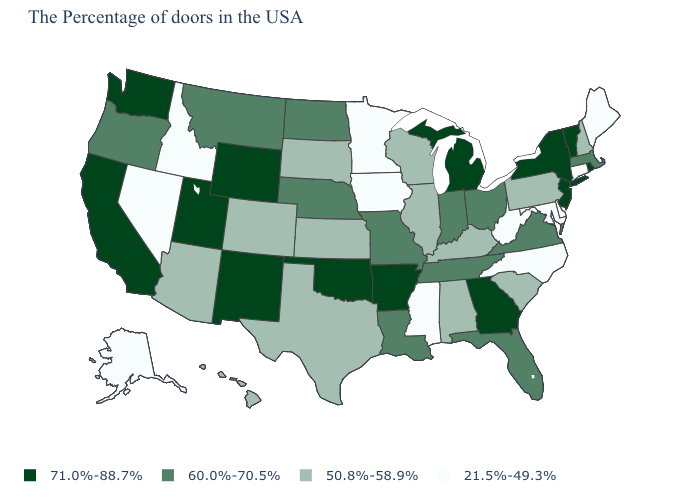Which states have the lowest value in the USA?
Give a very brief answer. Maine, Connecticut, Delaware, Maryland, North Carolina, West Virginia, Mississippi, Minnesota, Iowa, Idaho, Nevada, Alaska. Name the states that have a value in the range 50.8%-58.9%?
Keep it brief. New Hampshire, Pennsylvania, South Carolina, Kentucky, Alabama, Wisconsin, Illinois, Kansas, Texas, South Dakota, Colorado, Arizona, Hawaii. Does Alaska have the lowest value in the USA?
Concise answer only. Yes. What is the value of Oregon?
Short answer required. 60.0%-70.5%. Which states have the lowest value in the USA?
Give a very brief answer. Maine, Connecticut, Delaware, Maryland, North Carolina, West Virginia, Mississippi, Minnesota, Iowa, Idaho, Nevada, Alaska. What is the value of Kentucky?
Keep it brief. 50.8%-58.9%. Does New Hampshire have the highest value in the Northeast?
Be succinct. No. What is the value of Pennsylvania?
Give a very brief answer. 50.8%-58.9%. What is the value of Delaware?
Give a very brief answer. 21.5%-49.3%. Name the states that have a value in the range 21.5%-49.3%?
Keep it brief. Maine, Connecticut, Delaware, Maryland, North Carolina, West Virginia, Mississippi, Minnesota, Iowa, Idaho, Nevada, Alaska. Which states have the lowest value in the USA?
Give a very brief answer. Maine, Connecticut, Delaware, Maryland, North Carolina, West Virginia, Mississippi, Minnesota, Iowa, Idaho, Nevada, Alaska. Name the states that have a value in the range 71.0%-88.7%?
Quick response, please. Rhode Island, Vermont, New York, New Jersey, Georgia, Michigan, Arkansas, Oklahoma, Wyoming, New Mexico, Utah, California, Washington. Name the states that have a value in the range 71.0%-88.7%?
Quick response, please. Rhode Island, Vermont, New York, New Jersey, Georgia, Michigan, Arkansas, Oklahoma, Wyoming, New Mexico, Utah, California, Washington. Does Arizona have a lower value than Missouri?
Concise answer only. Yes. What is the value of Iowa?
Short answer required. 21.5%-49.3%. 